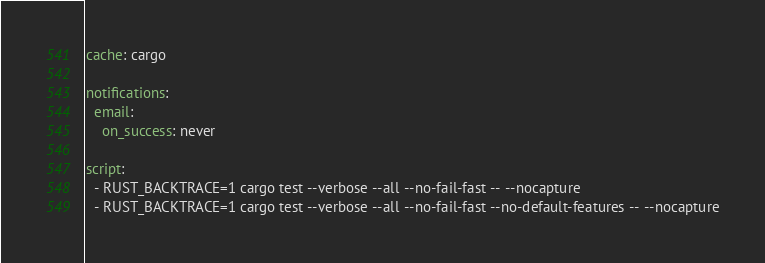Convert code to text. <code><loc_0><loc_0><loc_500><loc_500><_YAML_>cache: cargo

notifications:
  email:
    on_success: never

script:
  - RUST_BACKTRACE=1 cargo test --verbose --all --no-fail-fast -- --nocapture
  - RUST_BACKTRACE=1 cargo test --verbose --all --no-fail-fast --no-default-features -- --nocapture
</code> 